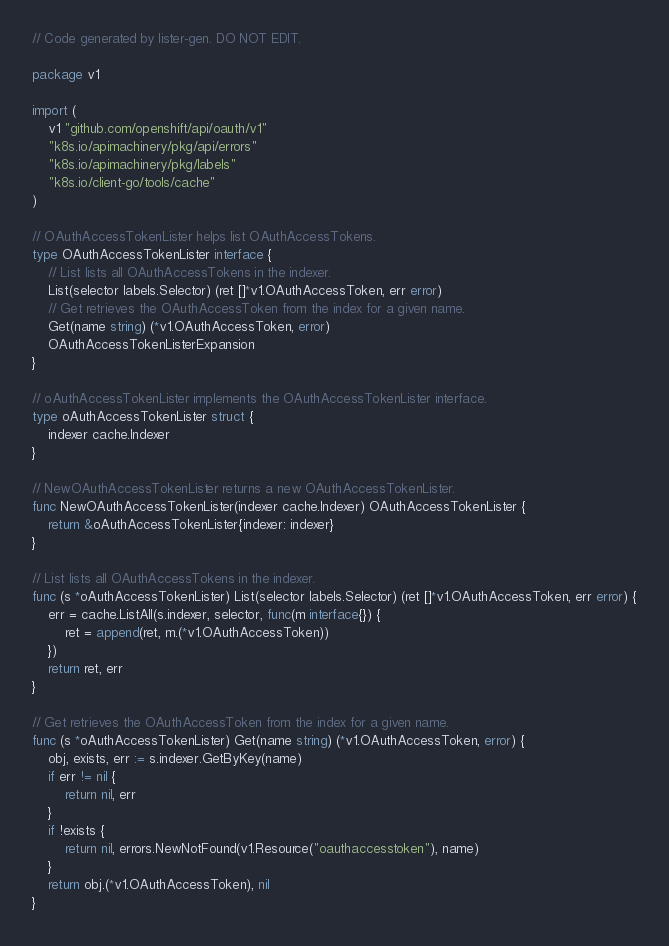Convert code to text. <code><loc_0><loc_0><loc_500><loc_500><_Go_>// Code generated by lister-gen. DO NOT EDIT.

package v1

import (
	v1 "github.com/openshift/api/oauth/v1"
	"k8s.io/apimachinery/pkg/api/errors"
	"k8s.io/apimachinery/pkg/labels"
	"k8s.io/client-go/tools/cache"
)

// OAuthAccessTokenLister helps list OAuthAccessTokens.
type OAuthAccessTokenLister interface {
	// List lists all OAuthAccessTokens in the indexer.
	List(selector labels.Selector) (ret []*v1.OAuthAccessToken, err error)
	// Get retrieves the OAuthAccessToken from the index for a given name.
	Get(name string) (*v1.OAuthAccessToken, error)
	OAuthAccessTokenListerExpansion
}

// oAuthAccessTokenLister implements the OAuthAccessTokenLister interface.
type oAuthAccessTokenLister struct {
	indexer cache.Indexer
}

// NewOAuthAccessTokenLister returns a new OAuthAccessTokenLister.
func NewOAuthAccessTokenLister(indexer cache.Indexer) OAuthAccessTokenLister {
	return &oAuthAccessTokenLister{indexer: indexer}
}

// List lists all OAuthAccessTokens in the indexer.
func (s *oAuthAccessTokenLister) List(selector labels.Selector) (ret []*v1.OAuthAccessToken, err error) {
	err = cache.ListAll(s.indexer, selector, func(m interface{}) {
		ret = append(ret, m.(*v1.OAuthAccessToken))
	})
	return ret, err
}

// Get retrieves the OAuthAccessToken from the index for a given name.
func (s *oAuthAccessTokenLister) Get(name string) (*v1.OAuthAccessToken, error) {
	obj, exists, err := s.indexer.GetByKey(name)
	if err != nil {
		return nil, err
	}
	if !exists {
		return nil, errors.NewNotFound(v1.Resource("oauthaccesstoken"), name)
	}
	return obj.(*v1.OAuthAccessToken), nil
}
</code> 